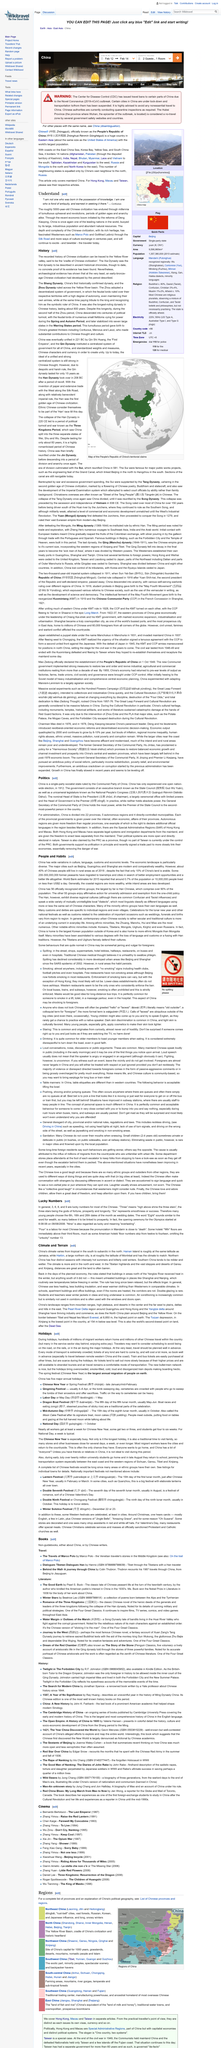Outline some significant characteristics in this image. The Chinese civilization is approximately five thousand years old, as stated. Through the millennia, Chinese civilization has experienced tumultuous upheaval and revolutions, as well as periods of golden ages and anarchy. These events have shaped the development and evolution of Chinese culture and society. The quote in the page under the topic "Understand" is attributed to Confucius. 